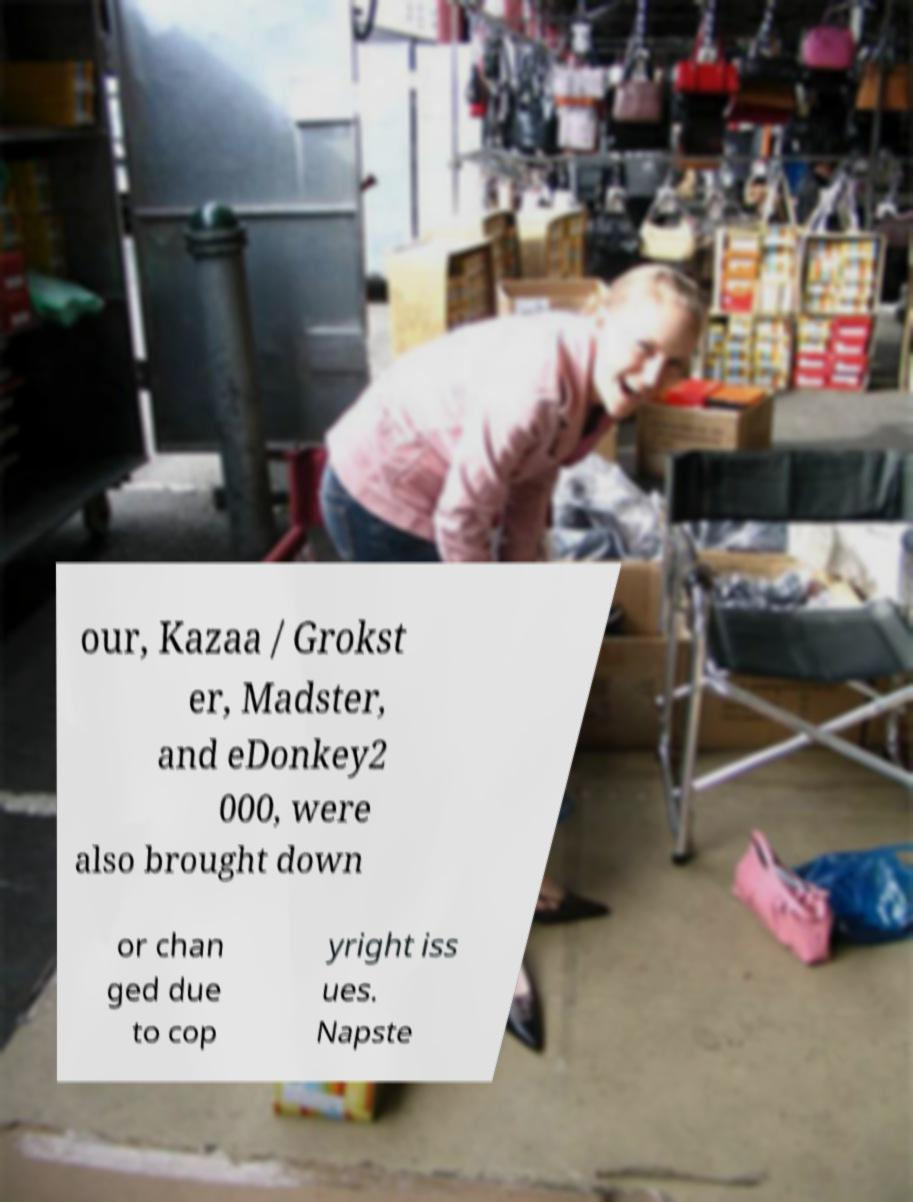For documentation purposes, I need the text within this image transcribed. Could you provide that? our, Kazaa / Grokst er, Madster, and eDonkey2 000, were also brought down or chan ged due to cop yright iss ues. Napste 